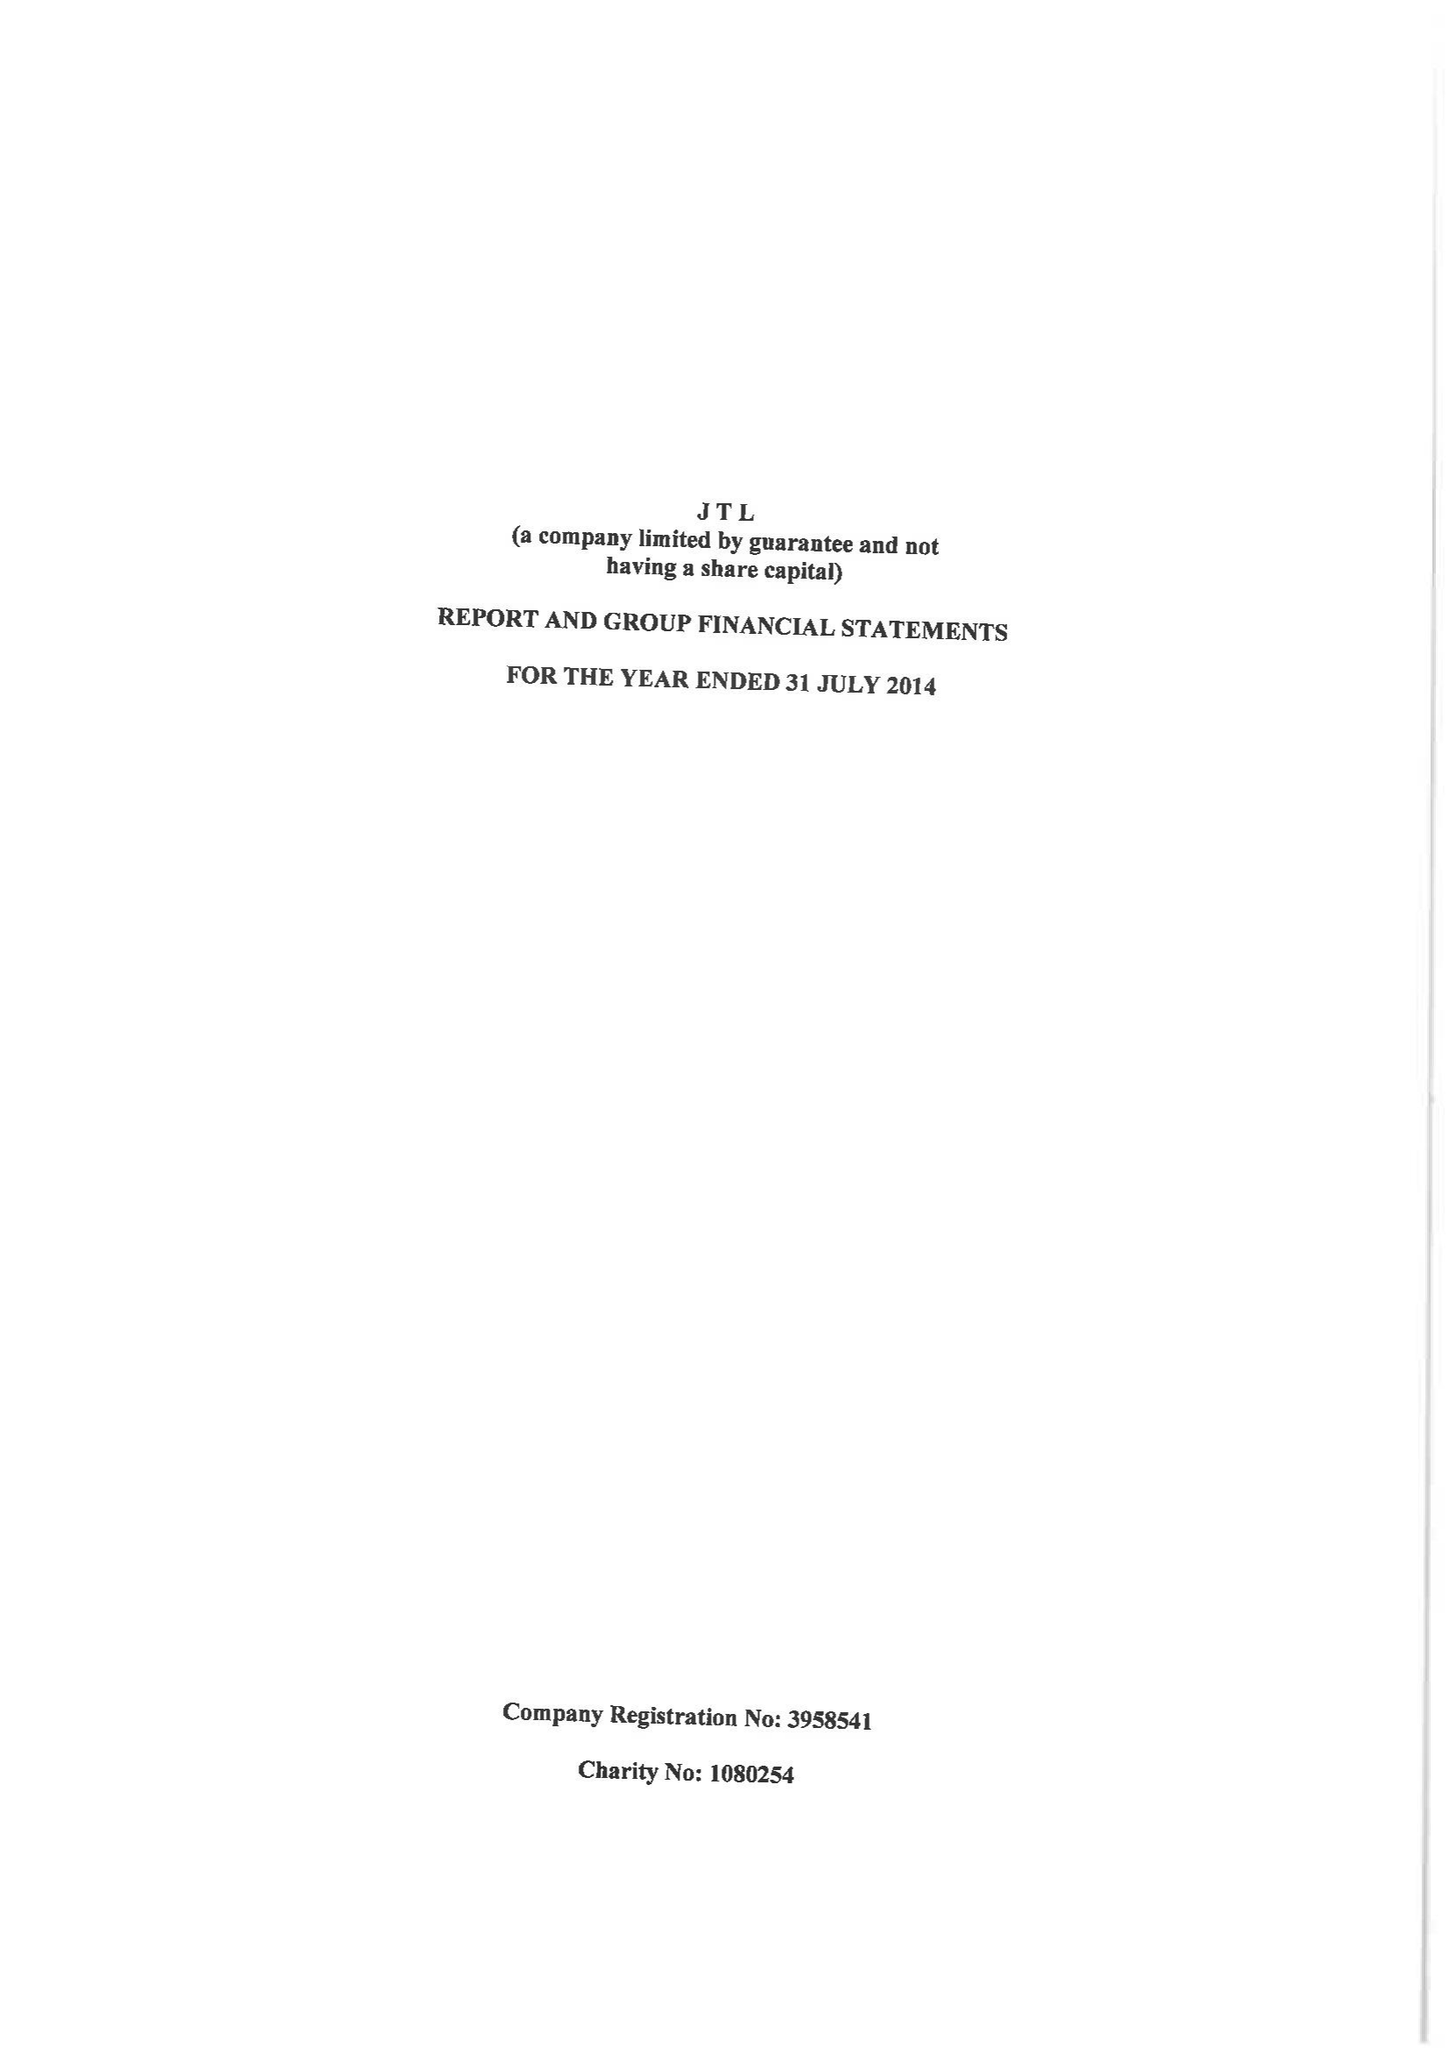What is the value for the report_date?
Answer the question using a single word or phrase. 2014-07-31 